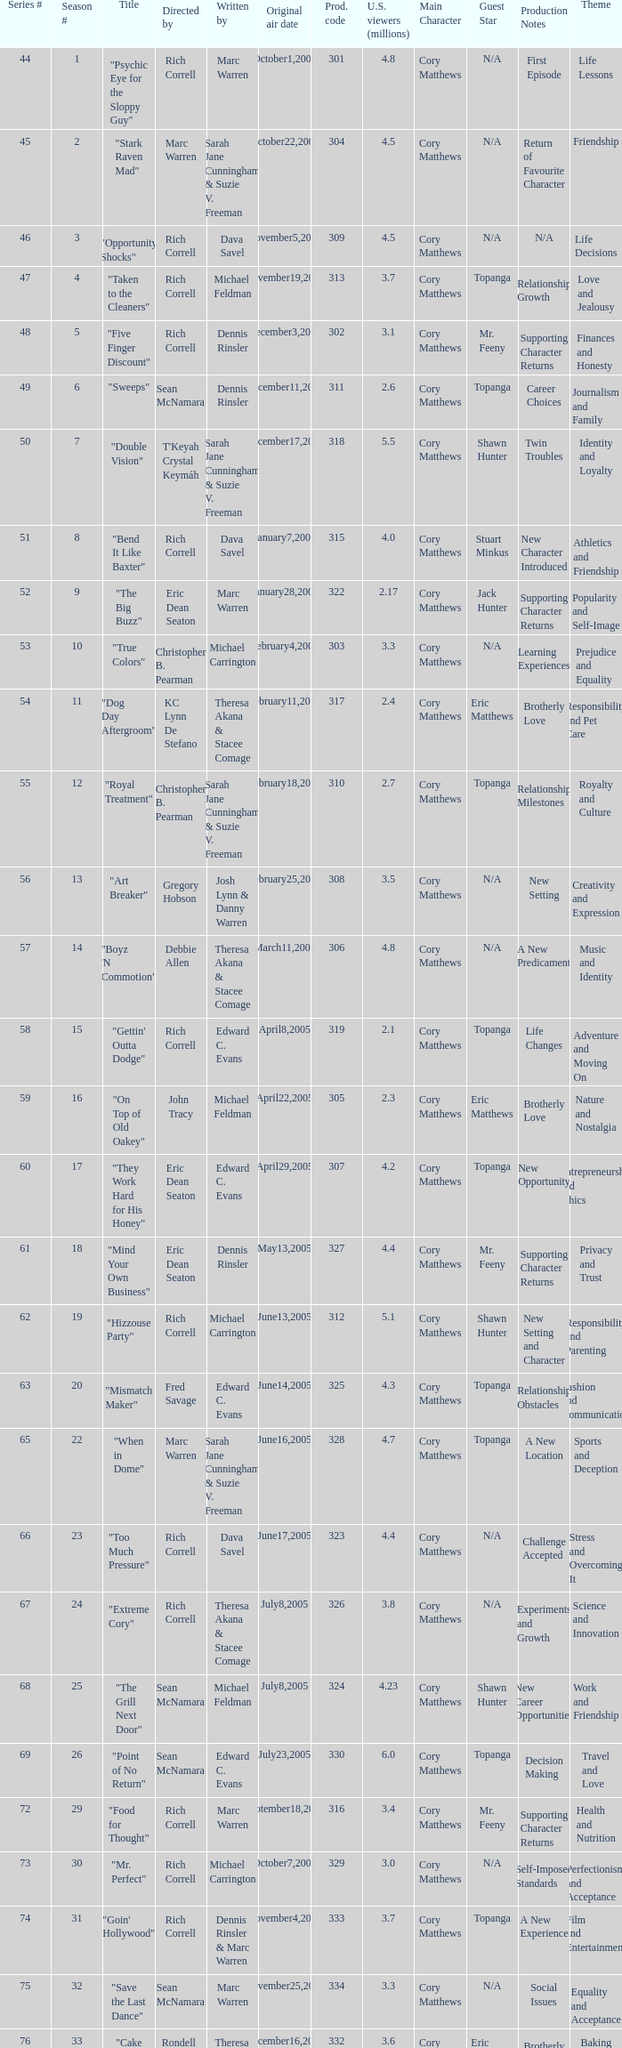What was the production code of the episode directed by Rondell Sheridan?  332.0. 